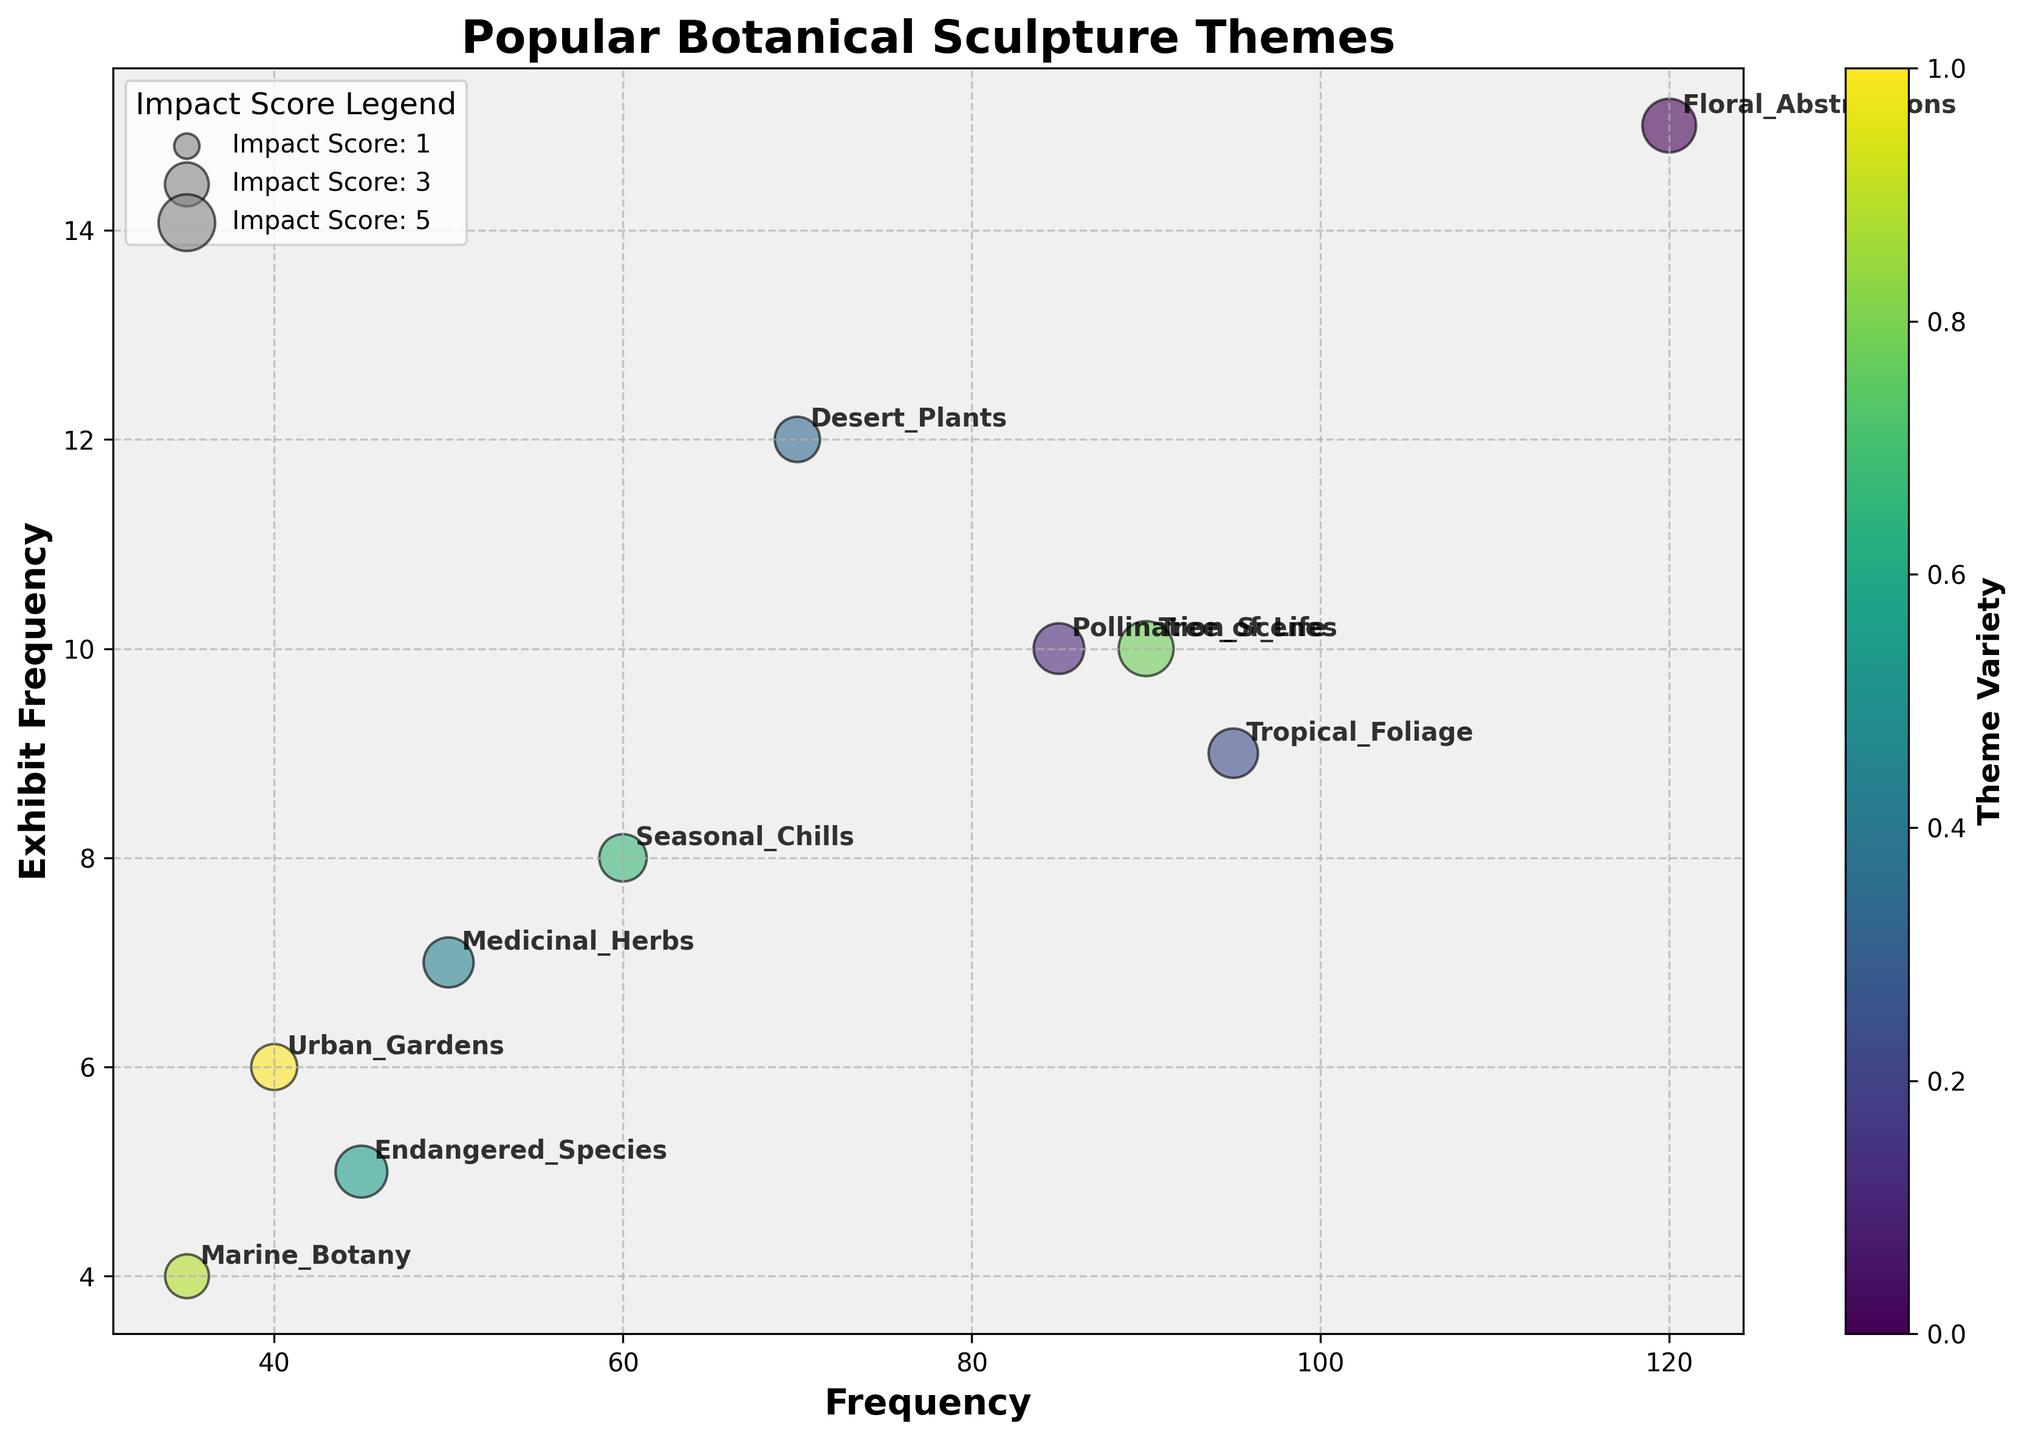What is the title of the figure? The title is at the top of the plot which prominently displays the main subject of the visualization.
Answer: Popular Botanical Sculpture Themes What are the x and y-axis labels in the chart? The x-axis label describes the horizontal axis, and the y-axis label describes the vertical axis, both of which give meaning to the chart's data points.
Answer: Frequency and Exhibit Frequency Which theme has the highest impact score based on the size of the bubbles? Larger bubbles represent higher impact scores, so you can visually compare the sizes of the bubbles to determine which is the largest.
Answer: Tree of Life How many themes have an Exhibit Frequency of exactly 10? The y-values of the chart correspond to Exhibit Frequency. Count the number of data points located at y = 10.
Answer: Three (Pollination Scenes, Tree of Life, and Pollination Scenes) Which theme has the lowest Exhibit Frequency? Look for the smallest value on the y-axis and identify the corresponding theme.
Answer: Marine Botany Compare the frequency of 'Floral Abstractions' and 'Endangered Species'. Which one is higher and by how much? Identify the x-values for 'Floral Abstractions' and 'Endangered Species' and calculate the difference.
Answer: Floral Abstractions is higher by 75 (120 - 45) Which theme appears to be the most frequent in art exhibits? The theme with the highest y-axis value represents the most frequent appearance in art exhibits.
Answer: Floral Abstractions What is the average Exhibit Frequency of 'Pollination Scenes', 'Tropical Foliage', and 'Desert Plants'? Sum their Exhibit Frequencies and divide by the number of themes: (10 + 9 + 12) / 3
Answer: 10.33 How does the Impact Score of 'Urban Gardens' compare to 'Desert Plants'? Compare the size of the bubbles, which corresponds to the Impact Score, and identify which is larger.
Answer: Desert Plants has a higher Impact Score Are there any themes with both high Frequency (≥ 90) and high Impact Score (≥ 4.0)? If so, which ones? Identify themes with x-values ≥ 90 and bubble sizes indicative of an Impact Score ≥ 4.0.
Answer: Tree of Life 